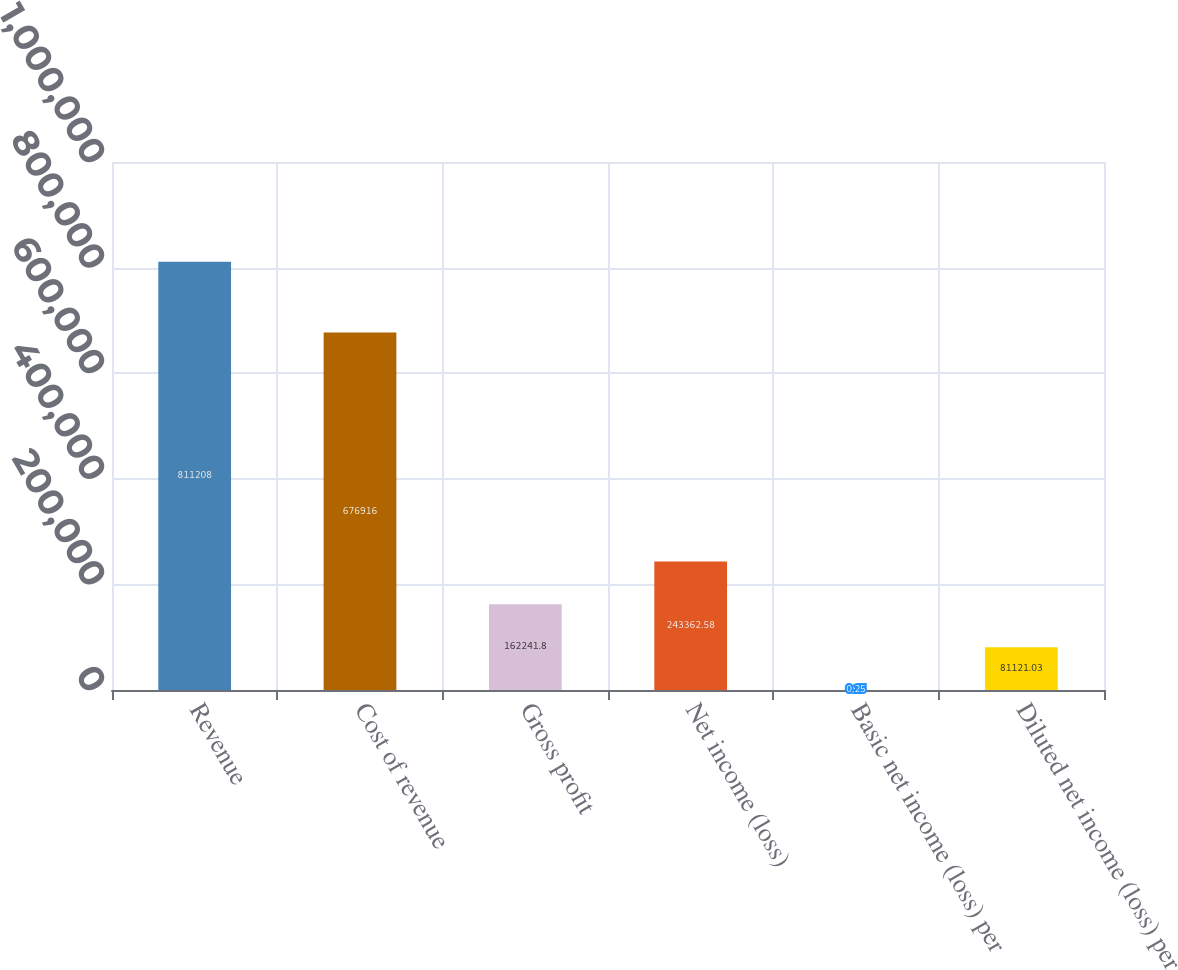<chart> <loc_0><loc_0><loc_500><loc_500><bar_chart><fcel>Revenue<fcel>Cost of revenue<fcel>Gross profit<fcel>Net income (loss)<fcel>Basic net income (loss) per<fcel>Diluted net income (loss) per<nl><fcel>811208<fcel>676916<fcel>162242<fcel>243363<fcel>0.25<fcel>81121<nl></chart> 